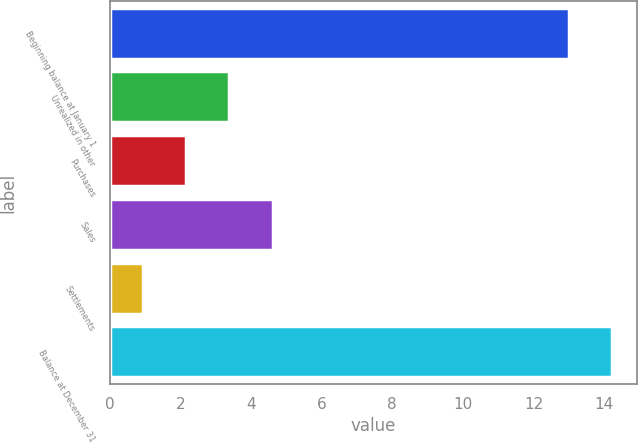<chart> <loc_0><loc_0><loc_500><loc_500><bar_chart><fcel>Beginning balance at January 1<fcel>Unrealized in other<fcel>Purchases<fcel>Sales<fcel>Settlements<fcel>Balance at December 31<nl><fcel>13<fcel>3.37<fcel>2.16<fcel>4.62<fcel>0.95<fcel>14.21<nl></chart> 